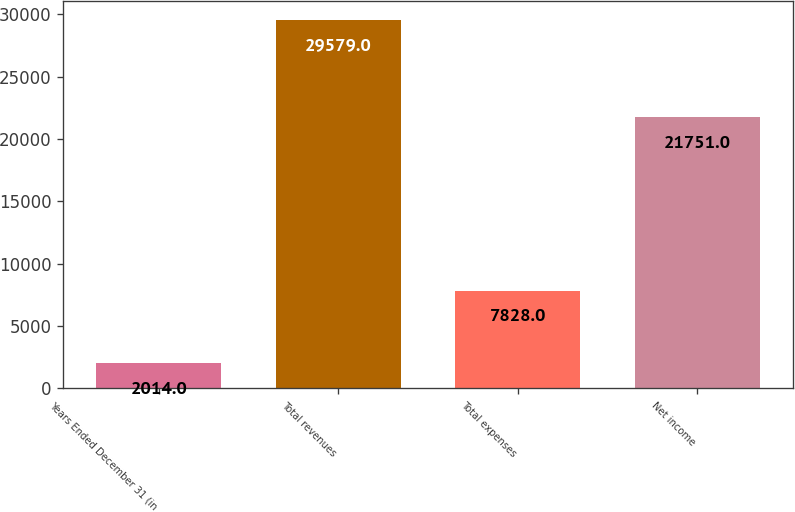<chart> <loc_0><loc_0><loc_500><loc_500><bar_chart><fcel>Years Ended December 31 (in<fcel>Total revenues<fcel>Total expenses<fcel>Net income<nl><fcel>2014<fcel>29579<fcel>7828<fcel>21751<nl></chart> 